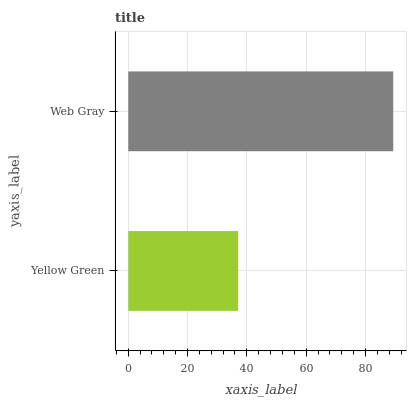Is Yellow Green the minimum?
Answer yes or no. Yes. Is Web Gray the maximum?
Answer yes or no. Yes. Is Web Gray the minimum?
Answer yes or no. No. Is Web Gray greater than Yellow Green?
Answer yes or no. Yes. Is Yellow Green less than Web Gray?
Answer yes or no. Yes. Is Yellow Green greater than Web Gray?
Answer yes or no. No. Is Web Gray less than Yellow Green?
Answer yes or no. No. Is Web Gray the high median?
Answer yes or no. Yes. Is Yellow Green the low median?
Answer yes or no. Yes. Is Yellow Green the high median?
Answer yes or no. No. Is Web Gray the low median?
Answer yes or no. No. 